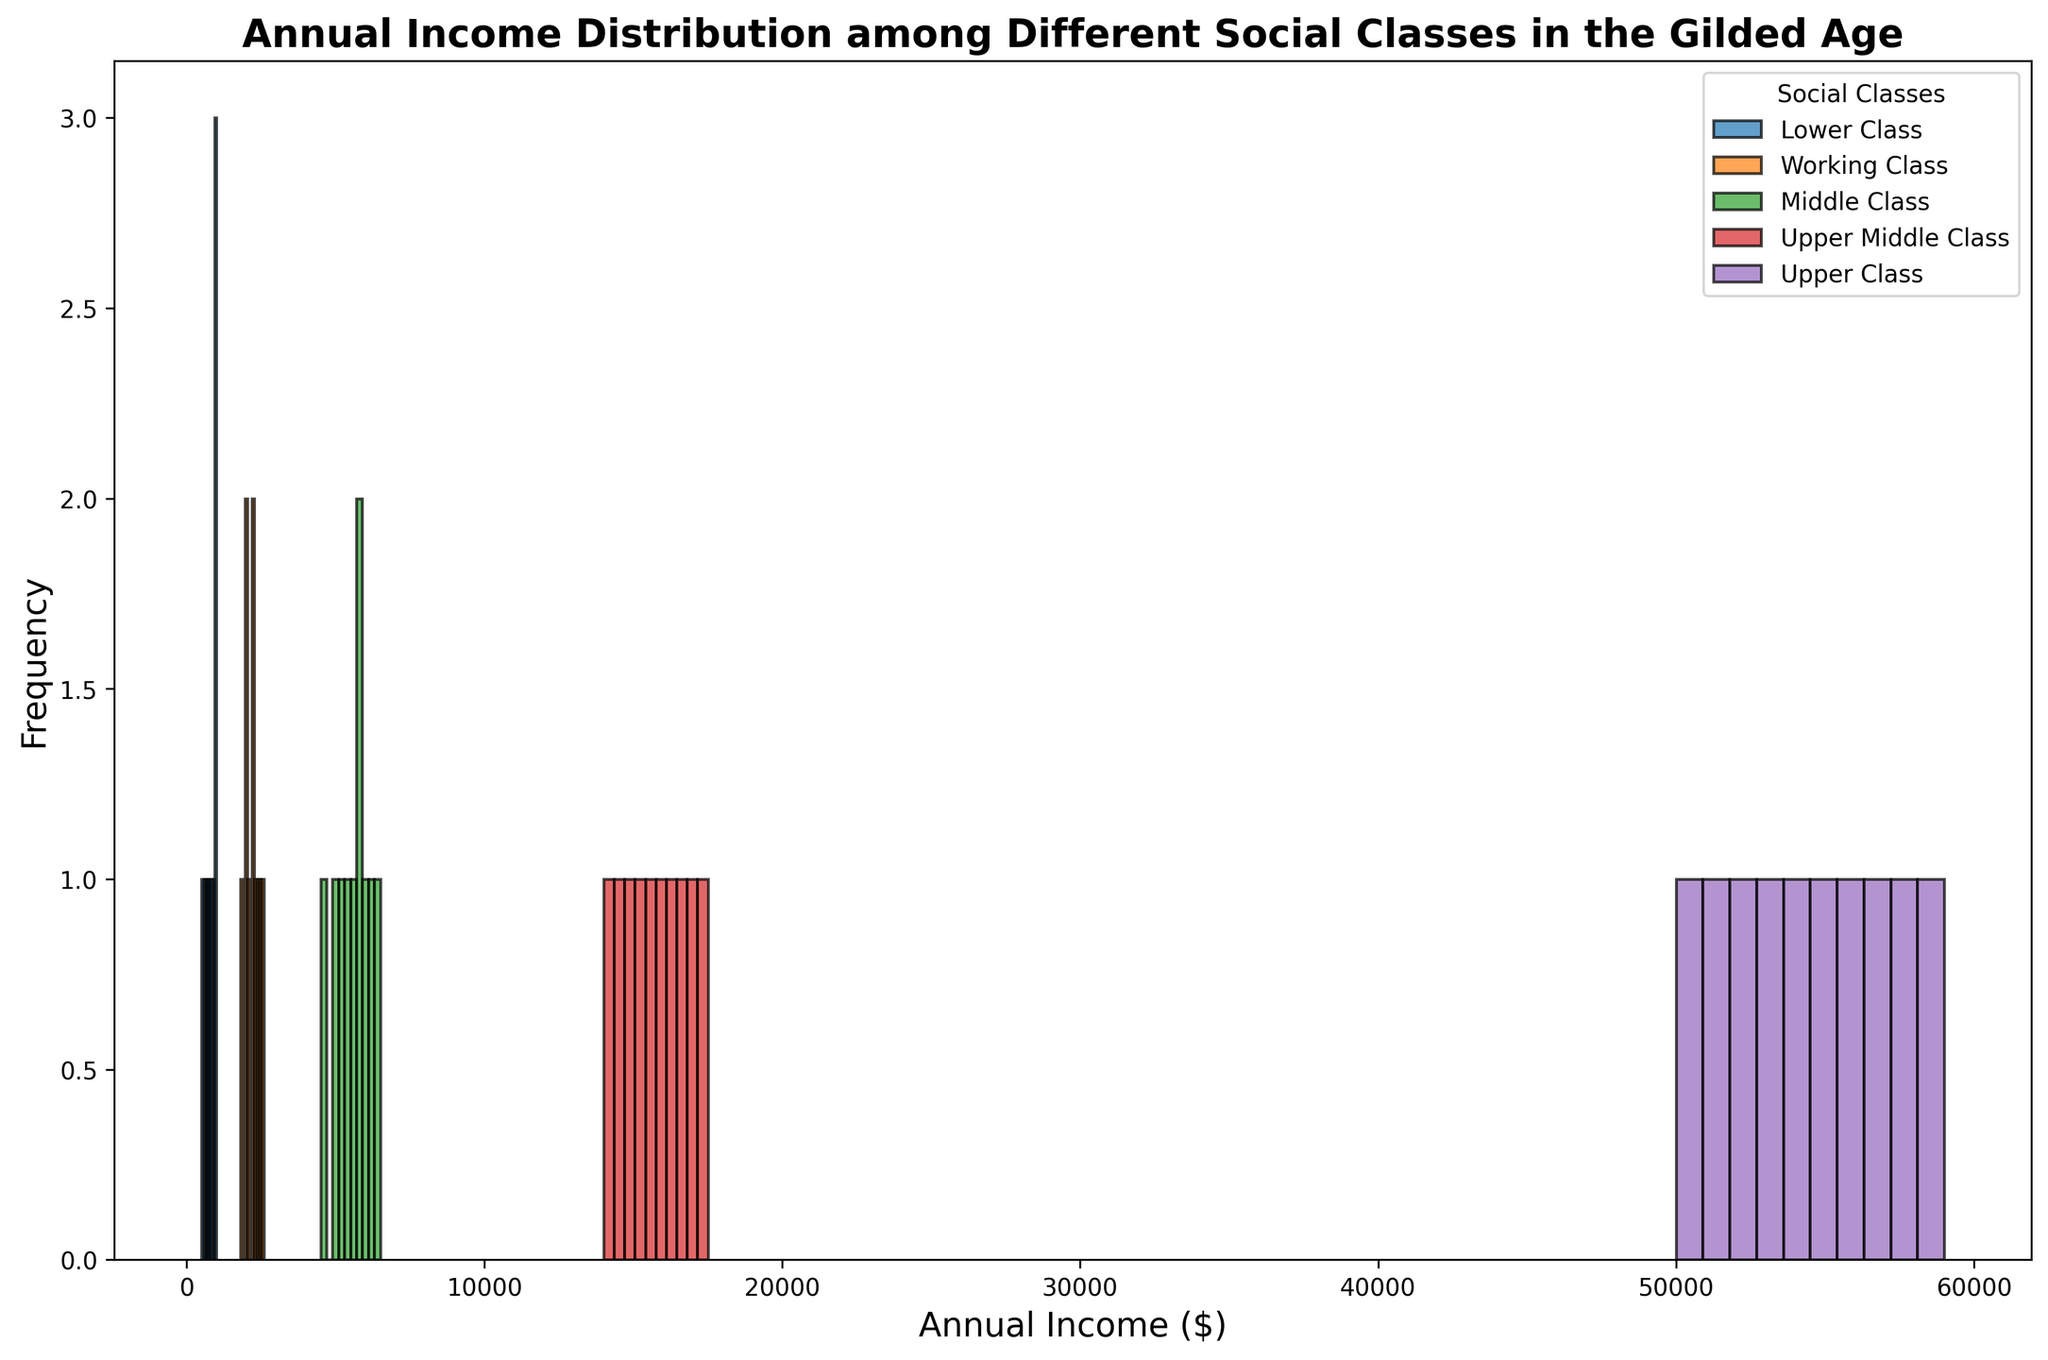What is the most common income range for the Lower Class? The histogram's highest bars for the Lower Class indicate the most common income range. By looking at the tallest bars for the Lower Class, we can see that the most common income range is $700 to $1000.
Answer: $700 to $1000 Which social class has the widest range of incomes? By comparing the range of incomes for each social class as indicated by the histograms, we see the Lower Class has incomes from $500 to $1000, the Working Class from $1800 to $2600, the Middle Class from $4500 to $6500, the Upper Middle Class from $14000 to $17500, and the Upper Class from $50000 to $59000. The Upper Class has the most spread-out range.
Answer: Upper Class How many social classes have an income mode that falls between $5000 and $7000? The mode is the income range with the highest frequency in the histogram. The Middle Class has a mode within $5000 to $7000, as seen by the tallest bars in that income range.
Answer: One What is the income range for the Working Class, and how does it compare to the Middle Class? The histogram shows the Working Class has incomes from $1800 to $2600, while the Middle Class has incomes from $4500 to $6500. Comparing the two ranges, the Working Class range is lower and narrower than the Middle Class.
Answer: $1800 to $2600 for the Working Class, $4500 to $6500 for the Middle Class Which social class has the highest density of income distribution within their range? Density can be inferred from the histogram bars' frequency and their spread. The Lower Class shows a tightly packed, high-frequency distribution within their income range ($500 to $1000), suggesting the highest density.
Answer: Lower Class What is the median income for the Upper Class, and how does it compare to the median income for the Middle Class? The median can be determined from the center value of each class's income range. For the Upper Class, the income values range from $50000 to $59000, so the median is around $54500. For the Middle Class, the median lies around $5500, the middle of the $4500 to $6500 range.
Answer: $54500 for Upper Class, $5500 for Middle Class How does the income distribution of the Upper Middle Class compare to that of the Upper Class in terms of range and frequency? The histogram for the Upper Middle Class shows a range from $14000 to $17500, with relatively even frequency throughout. The Upper Class's range is from $50000 to $59000, which is much wider, but the frequency distribution is more dense towards the lower end of the range. This indicates that despite having higher overall incomes, the Upper Class has a broader distribution in comparison to the Upper Middle Class's more evenly spread distribution.
Answer: Upper Middle Class: $14000 to $17500, even frequency; Upper Class: $50000 to $59000, dense at lower end What color represents the Middle Class income distribution, and what is its associated range? In the histogram, the Middle Class is represented by the green color. Its income distribution range is $4500 to $6500.
Answer: Green, $4500 to $6500 Which social class has the least overlap with any other class in their income distribution? Overlap can be seen where income ranges intersect. The Upper Class with incomes from $50000 to $59000 does not overlap with any other class, having a uniquely high range.
Answer: Upper Class What income range for the Lower Class has the highest frequency, and how does it compare to the highest frequency range of the Upper Middle Class? From the histogram, the highest frequency range for the Lower Class is $700 to $1000. For the Upper Middle Class, the highest frequency range is $15000 to $17000. Comparing the highest frequency ranges, the Upper Middle Class's range is significantly higher.
Answer: $700 to $1000 for Lower Class; $15000 to $17000 for Upper Middle Class 